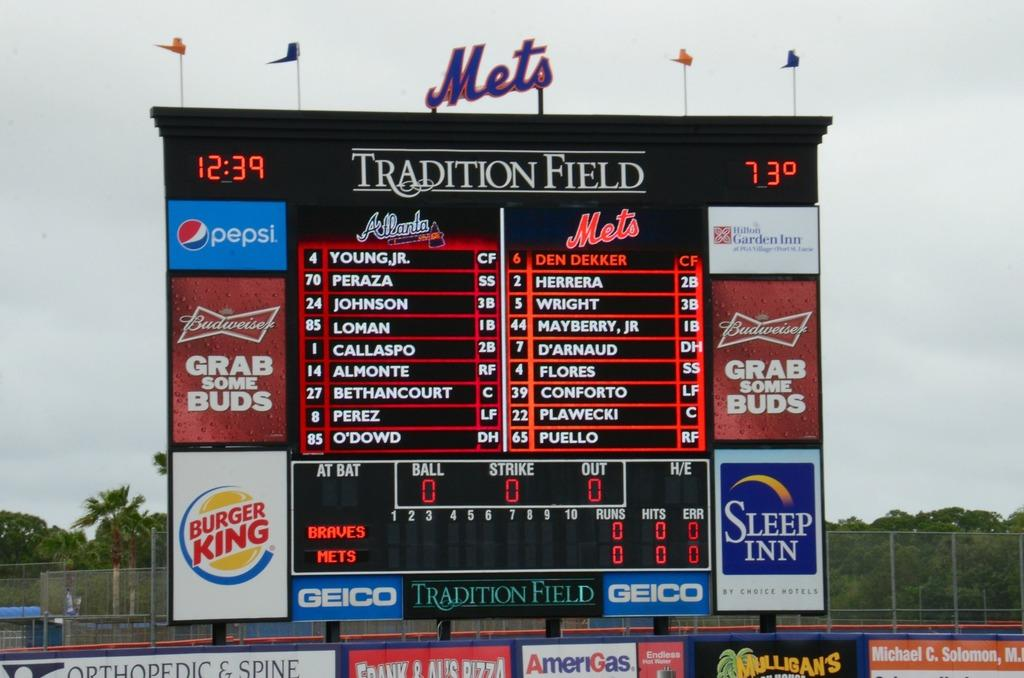<image>
Present a compact description of the photo's key features. Baseball scoreboard that shows the temperature currently at 73. 